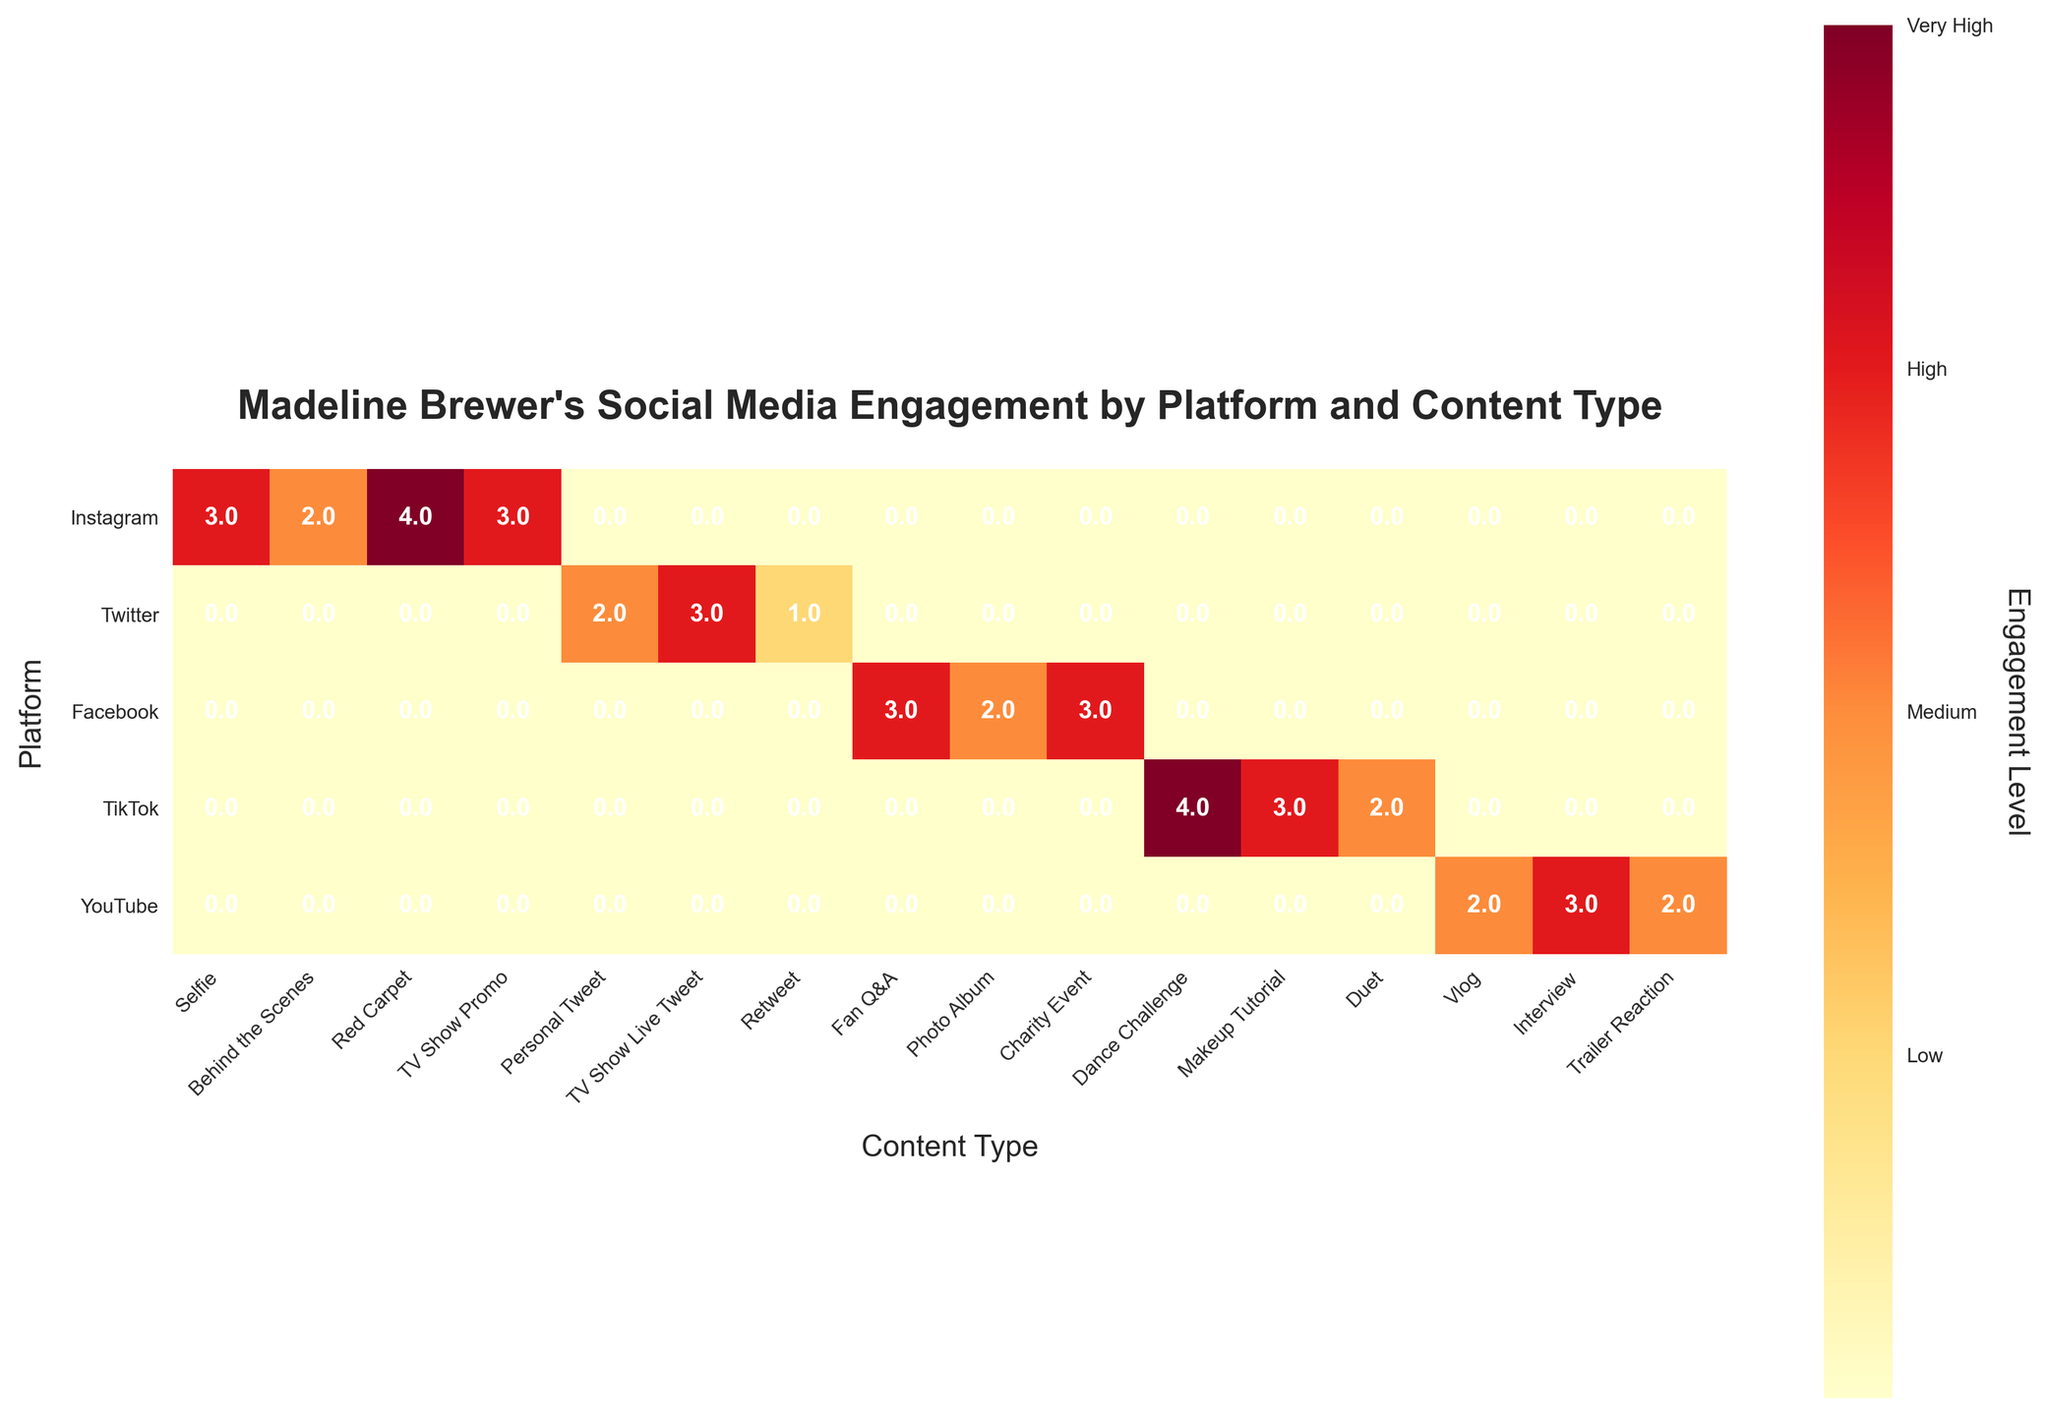What is the title of the mosaic plot? The title is written at the top of the figure in bold.
Answer: Madeline Brewer's Social Media Engagement by Platform and Content Type Which platform has the highest engagement level for 'Dance Challenge' content? Locate the 'Dance Challenge' column, then find the row for the platform with the highest engagement level color.
Answer: TikTok What is the engagement level for 'Retweet' content on Twitter? Find the 'Retweet' column and follow it to the Twitter row, then read the engagement level from the color bar.
Answer: Low Which two platforms have 'High' engagement levels for 'Charity Event' content? Locate the 'Charity Event' column, then identify the platforms in that column with the 'High' engagement color according to the color bar.
Answer: Facebook and Instagram How many different engagement levels are represented in the plot? Count the different engagement levels shown in the color bar on the side of the plot.
Answer: Four Which content type has the most diverse engagement levels across all platforms? Check the columns one by one and see which column has the highest variety of color shades corresponding to different engagement levels.
Answer: TV Show Promo Compare the engagement level of 'TV Show Promo' content on Instagram with 'TV Show Live Tweet' on Twitter. Which has a higher engagement level? Locate the relevant columns for 'TV Show Promo' on Instagram and 'TV Show Live Tweet' on Twitter and compare their colors using the color bar.
Answer: TV Show Live Tweet on Twitter What is the average engagement level of 'Interview' content on YouTube and 'Makeup Tutorial' on TikTok? Find the engagement levels for both content types, convert them to their numeric values, add them, and divide by 2. (High = 3 for each, so (3 + 3) / 2 = 3)
Answer: 3 (High) Which platform has the highest 'Medium' engagement level content type count? Count the 'Medium' color shades in each row/platform across all content types and identify the platform with the highest count.
Answer: YouTube 